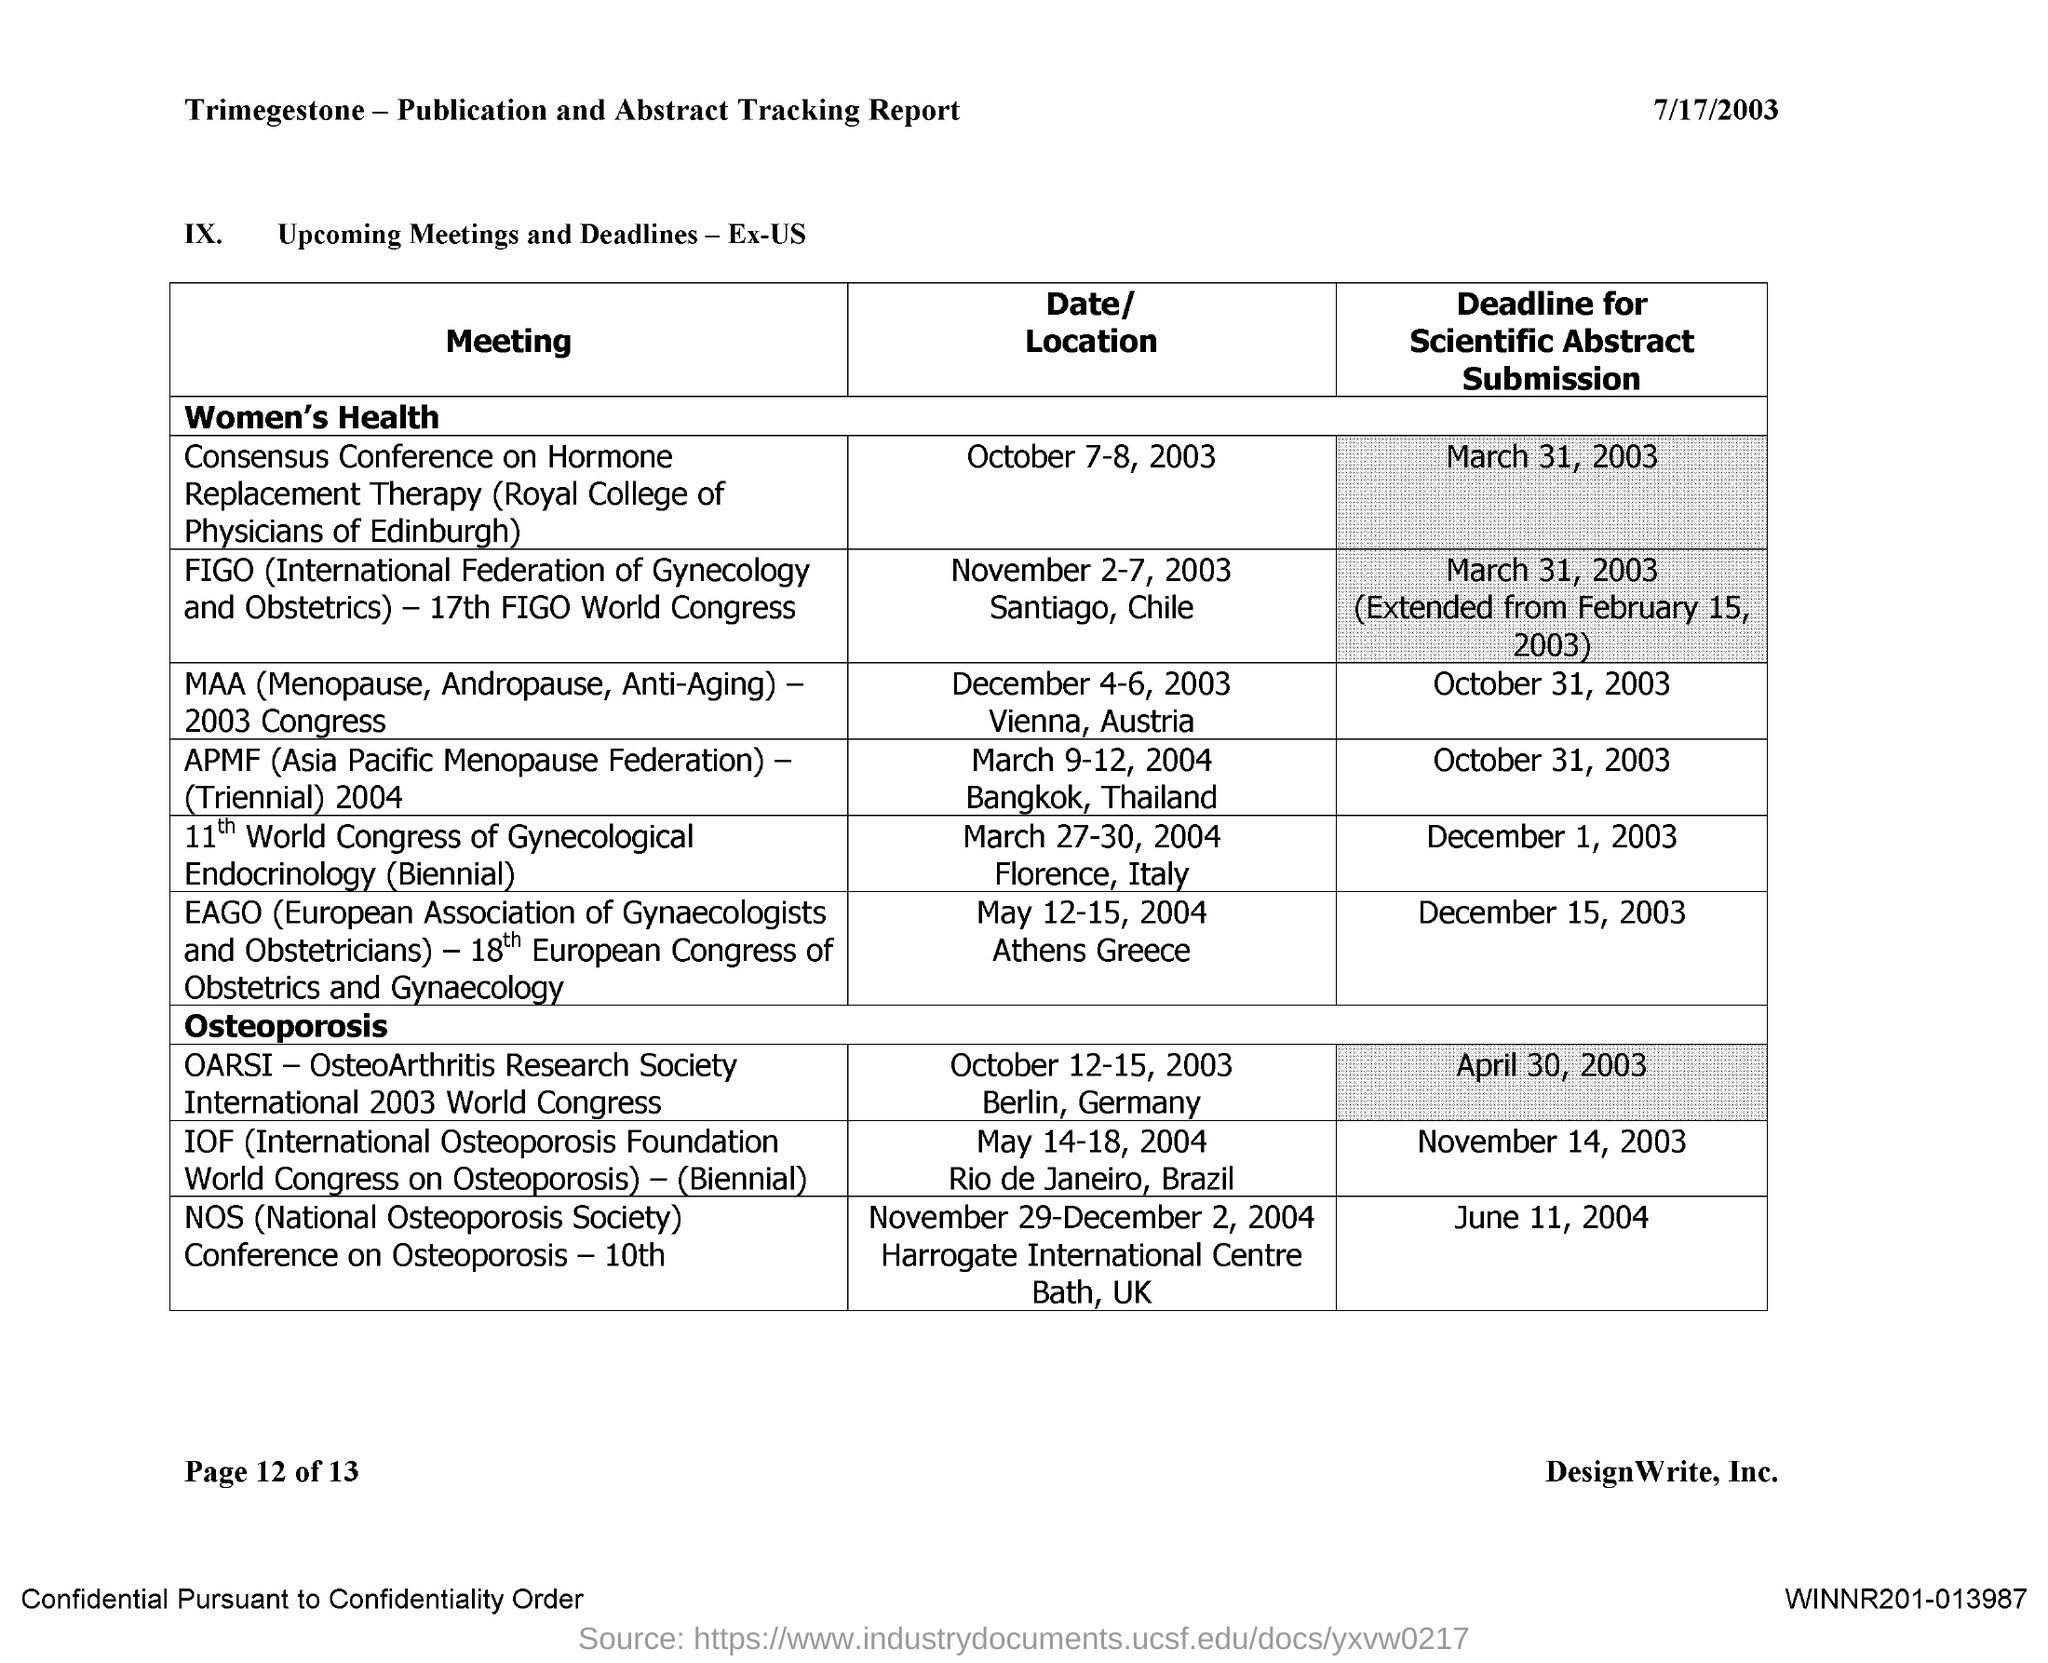What is the Date written on top left of page
Ensure brevity in your answer.  7/17/2003. 